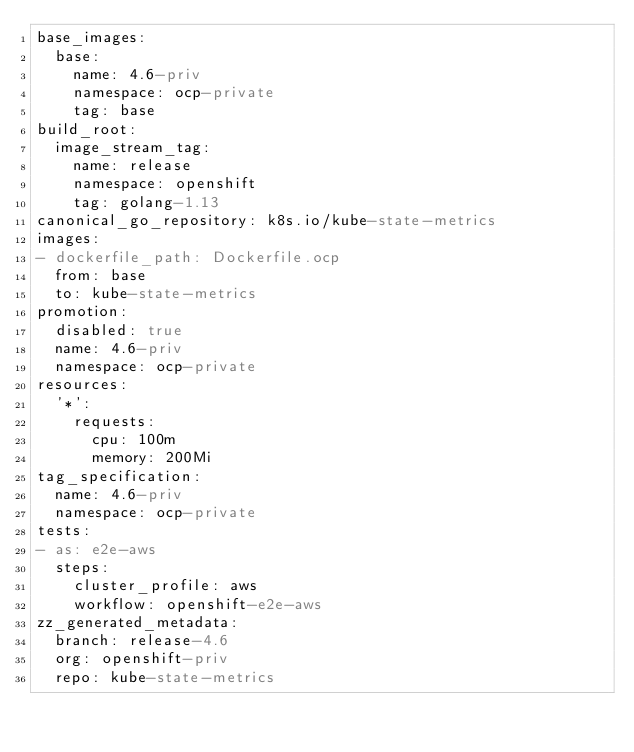Convert code to text. <code><loc_0><loc_0><loc_500><loc_500><_YAML_>base_images:
  base:
    name: 4.6-priv
    namespace: ocp-private
    tag: base
build_root:
  image_stream_tag:
    name: release
    namespace: openshift
    tag: golang-1.13
canonical_go_repository: k8s.io/kube-state-metrics
images:
- dockerfile_path: Dockerfile.ocp
  from: base
  to: kube-state-metrics
promotion:
  disabled: true
  name: 4.6-priv
  namespace: ocp-private
resources:
  '*':
    requests:
      cpu: 100m
      memory: 200Mi
tag_specification:
  name: 4.6-priv
  namespace: ocp-private
tests:
- as: e2e-aws
  steps:
    cluster_profile: aws
    workflow: openshift-e2e-aws
zz_generated_metadata:
  branch: release-4.6
  org: openshift-priv
  repo: kube-state-metrics
</code> 